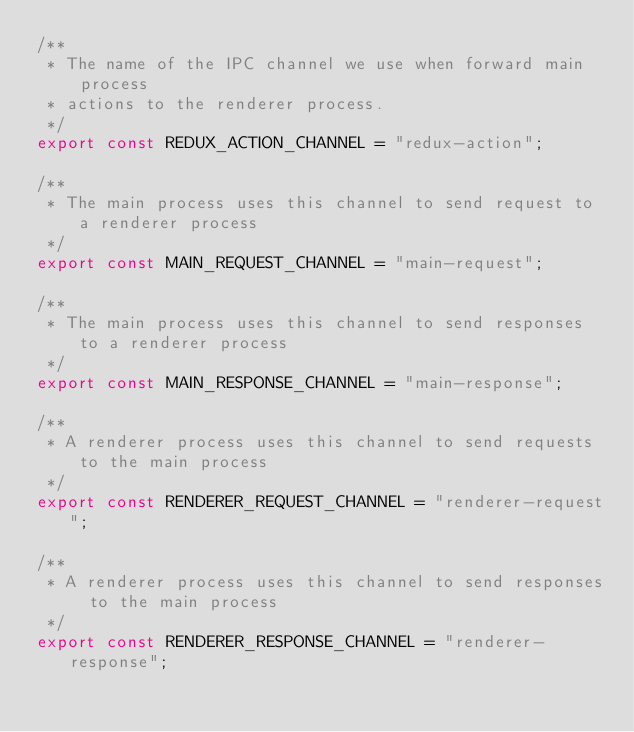<code> <loc_0><loc_0><loc_500><loc_500><_TypeScript_>/**
 * The name of the IPC channel we use when forward main process
 * actions to the renderer process.
 */
export const REDUX_ACTION_CHANNEL = "redux-action";

/**
 * The main process uses this channel to send request to a renderer process
 */
export const MAIN_REQUEST_CHANNEL = "main-request";

/**
 * The main process uses this channel to send responses to a renderer process
 */
export const MAIN_RESPONSE_CHANNEL = "main-response";

/**
 * A renderer process uses this channel to send requests to the main process
 */
export const RENDERER_REQUEST_CHANNEL = "renderer-request";

/**
 * A renderer process uses this channel to send responses to the main process
 */
export const RENDERER_RESPONSE_CHANNEL = "renderer-response";</code> 